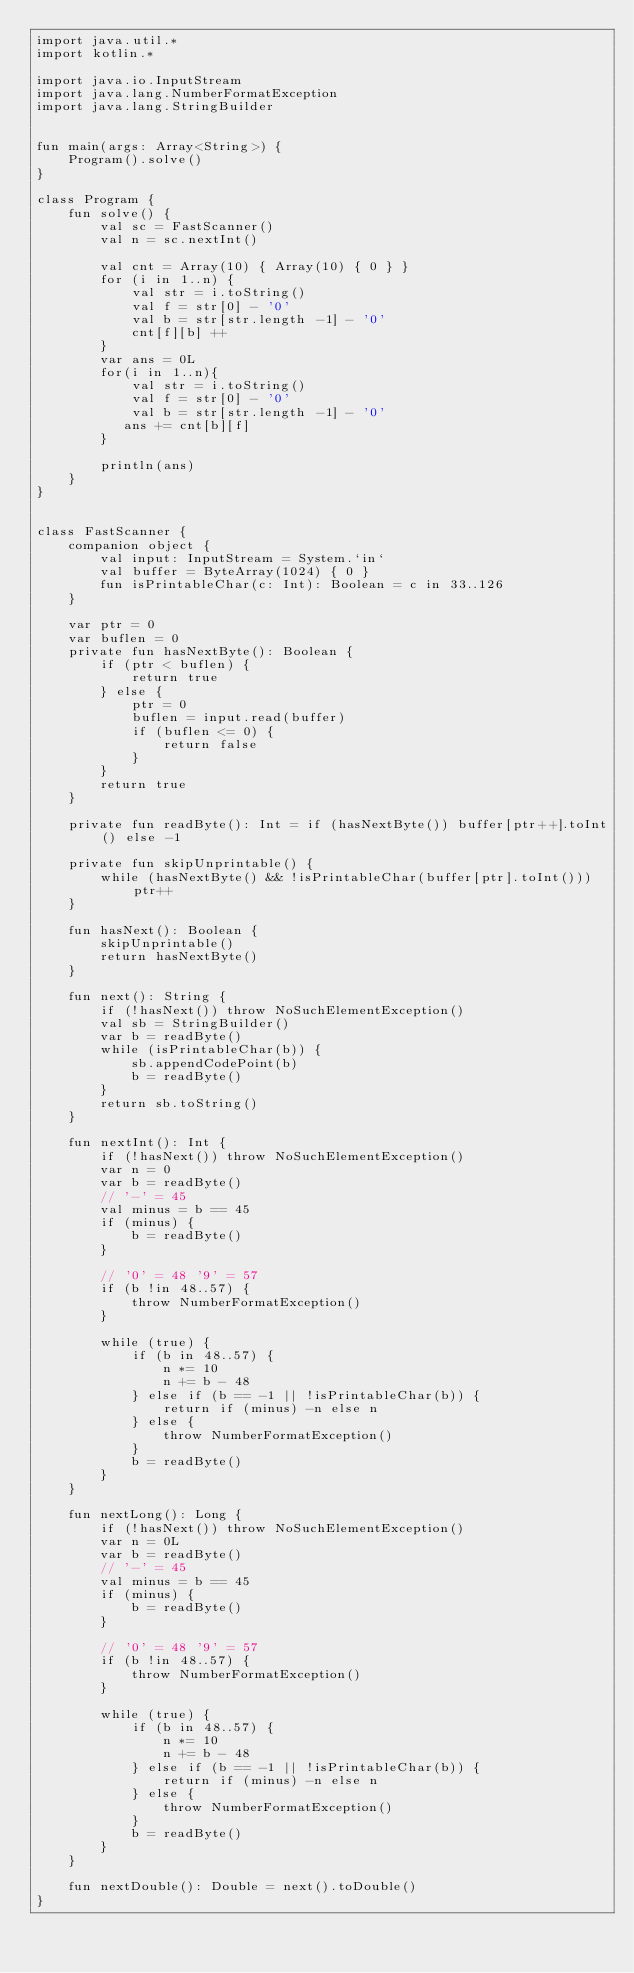<code> <loc_0><loc_0><loc_500><loc_500><_Kotlin_>import java.util.*
import kotlin.*

import java.io.InputStream
import java.lang.NumberFormatException
import java.lang.StringBuilder


fun main(args: Array<String>) {
    Program().solve()
}

class Program {
    fun solve() {
        val sc = FastScanner()
        val n = sc.nextInt()

        val cnt = Array(10) { Array(10) { 0 } }
        for (i in 1..n) {
            val str = i.toString()
            val f = str[0] - '0'
            val b = str[str.length -1] - '0'
            cnt[f][b] ++
        }
        var ans = 0L
        for(i in 1..n){
            val str = i.toString()
            val f = str[0] - '0'
            val b = str[str.length -1] - '0'
           ans += cnt[b][f]
        }

        println(ans)
    }
}


class FastScanner {
    companion object {
        val input: InputStream = System.`in`
        val buffer = ByteArray(1024) { 0 }
        fun isPrintableChar(c: Int): Boolean = c in 33..126
    }

    var ptr = 0
    var buflen = 0
    private fun hasNextByte(): Boolean {
        if (ptr < buflen) {
            return true
        } else {
            ptr = 0
            buflen = input.read(buffer)
            if (buflen <= 0) {
                return false
            }
        }
        return true
    }

    private fun readByte(): Int = if (hasNextByte()) buffer[ptr++].toInt() else -1

    private fun skipUnprintable() {
        while (hasNextByte() && !isPrintableChar(buffer[ptr].toInt())) ptr++
    }

    fun hasNext(): Boolean {
        skipUnprintable()
        return hasNextByte()
    }

    fun next(): String {
        if (!hasNext()) throw NoSuchElementException()
        val sb = StringBuilder()
        var b = readByte()
        while (isPrintableChar(b)) {
            sb.appendCodePoint(b)
            b = readByte()
        }
        return sb.toString()
    }

    fun nextInt(): Int {
        if (!hasNext()) throw NoSuchElementException()
        var n = 0
        var b = readByte()
        // '-' = 45
        val minus = b == 45
        if (minus) {
            b = readByte()
        }

        // '0' = 48 '9' = 57
        if (b !in 48..57) {
            throw NumberFormatException()
        }

        while (true) {
            if (b in 48..57) {
                n *= 10
                n += b - 48
            } else if (b == -1 || !isPrintableChar(b)) {
                return if (minus) -n else n
            } else {
                throw NumberFormatException()
            }
            b = readByte()
        }
    }

    fun nextLong(): Long {
        if (!hasNext()) throw NoSuchElementException()
        var n = 0L
        var b = readByte()
        // '-' = 45
        val minus = b == 45
        if (minus) {
            b = readByte()
        }

        // '0' = 48 '9' = 57
        if (b !in 48..57) {
            throw NumberFormatException()
        }

        while (true) {
            if (b in 48..57) {
                n *= 10
                n += b - 48
            } else if (b == -1 || !isPrintableChar(b)) {
                return if (minus) -n else n
            } else {
                throw NumberFormatException()
            }
            b = readByte()
        }
    }

    fun nextDouble(): Double = next().toDouble()
}
</code> 